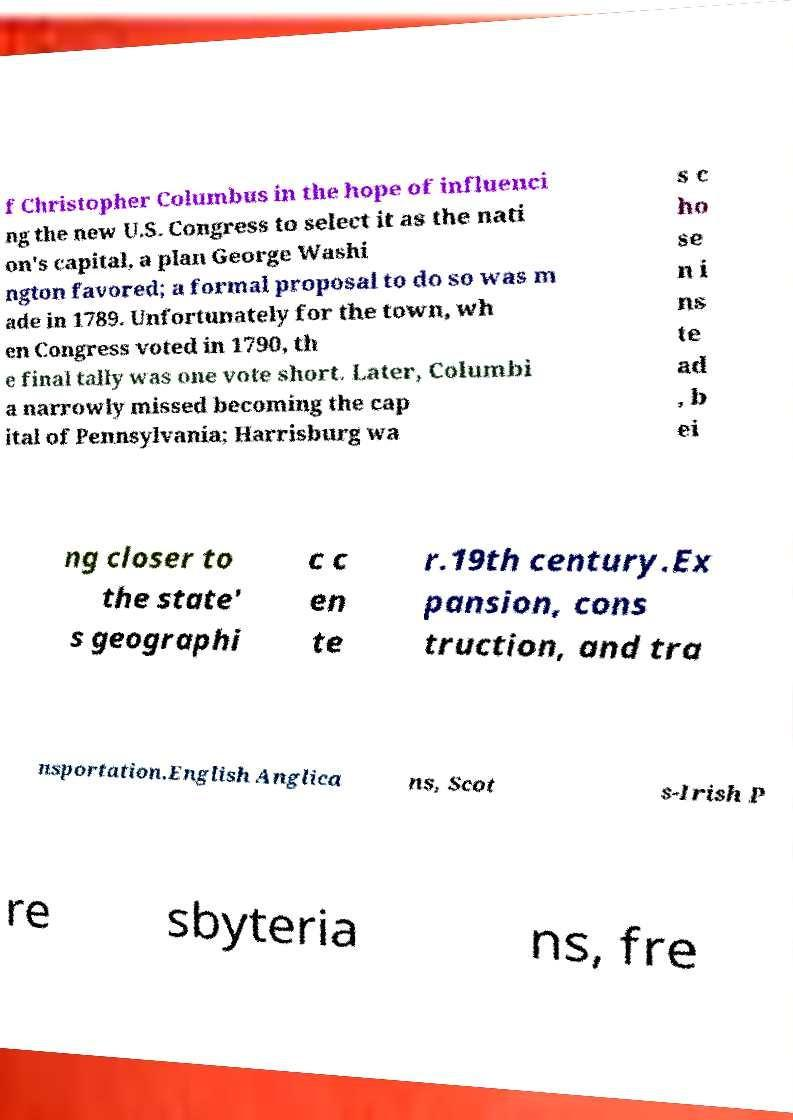Could you assist in decoding the text presented in this image and type it out clearly? f Christopher Columbus in the hope of influenci ng the new U.S. Congress to select it as the nati on's capital, a plan George Washi ngton favored; a formal proposal to do so was m ade in 1789. Unfortunately for the town, wh en Congress voted in 1790, th e final tally was one vote short. Later, Columbi a narrowly missed becoming the cap ital of Pennsylvania; Harrisburg wa s c ho se n i ns te ad , b ei ng closer to the state' s geographi c c en te r.19th century.Ex pansion, cons truction, and tra nsportation.English Anglica ns, Scot s-Irish P re sbyteria ns, fre 